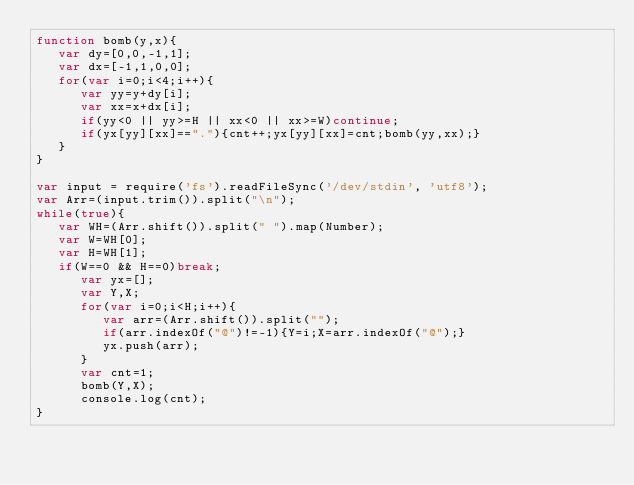<code> <loc_0><loc_0><loc_500><loc_500><_JavaScript_>function bomb(y,x){
   var dy=[0,0,-1,1];
   var dx=[-1,1,0,0];
   for(var i=0;i<4;i++){
      var yy=y+dy[i];
      var xx=x+dx[i];
      if(yy<0 || yy>=H || xx<0 || xx>=W)continue;
      if(yx[yy][xx]=="."){cnt++;yx[yy][xx]=cnt;bomb(yy,xx);}
   }
}

var input = require('fs').readFileSync('/dev/stdin', 'utf8');
var Arr=(input.trim()).split("\n");
while(true){
   var WH=(Arr.shift()).split(" ").map(Number);
   var W=WH[0];
   var H=WH[1];
   if(W==0 && H==0)break;
      var yx=[];
      var Y,X;
      for(var i=0;i<H;i++){
         var arr=(Arr.shift()).split("");
         if(arr.indexOf("@")!=-1){Y=i;X=arr.indexOf("@");}
         yx.push(arr);
      }
      var cnt=1;
      bomb(Y,X);
      console.log(cnt);
}</code> 